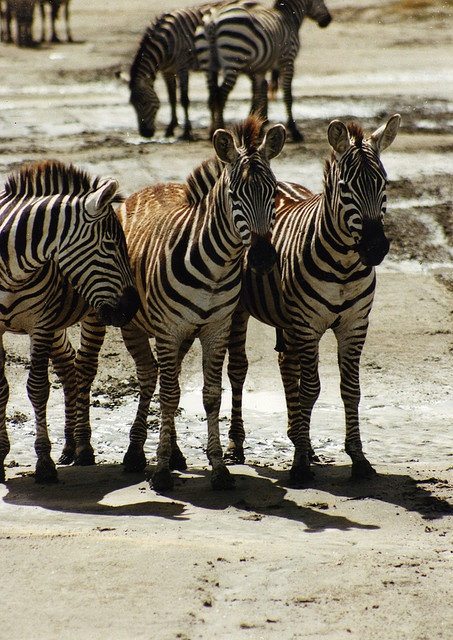Describe the objects in this image and their specific colors. I can see zebra in black and gray tones, zebra in black and gray tones, zebra in black, olive, and gray tones, zebra in black and gray tones, and zebra in black and gray tones in this image. 